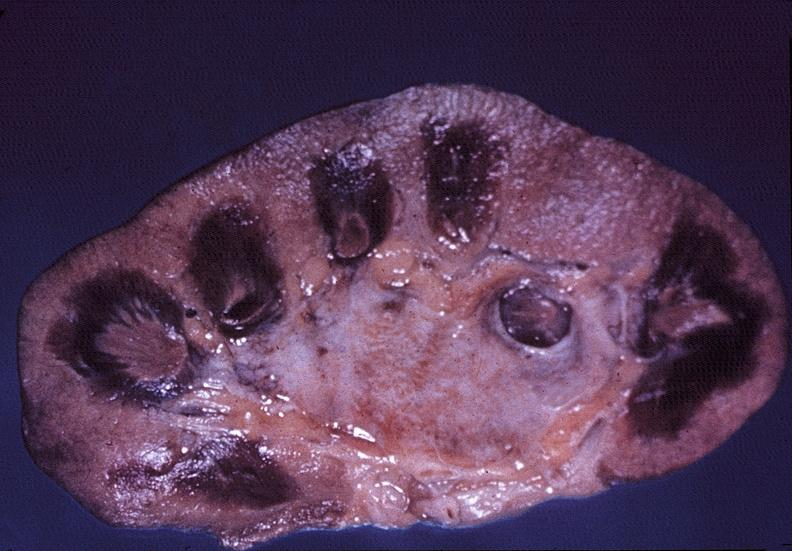what necrotizing?
Answer the question using a single word or phrase. Kidney 